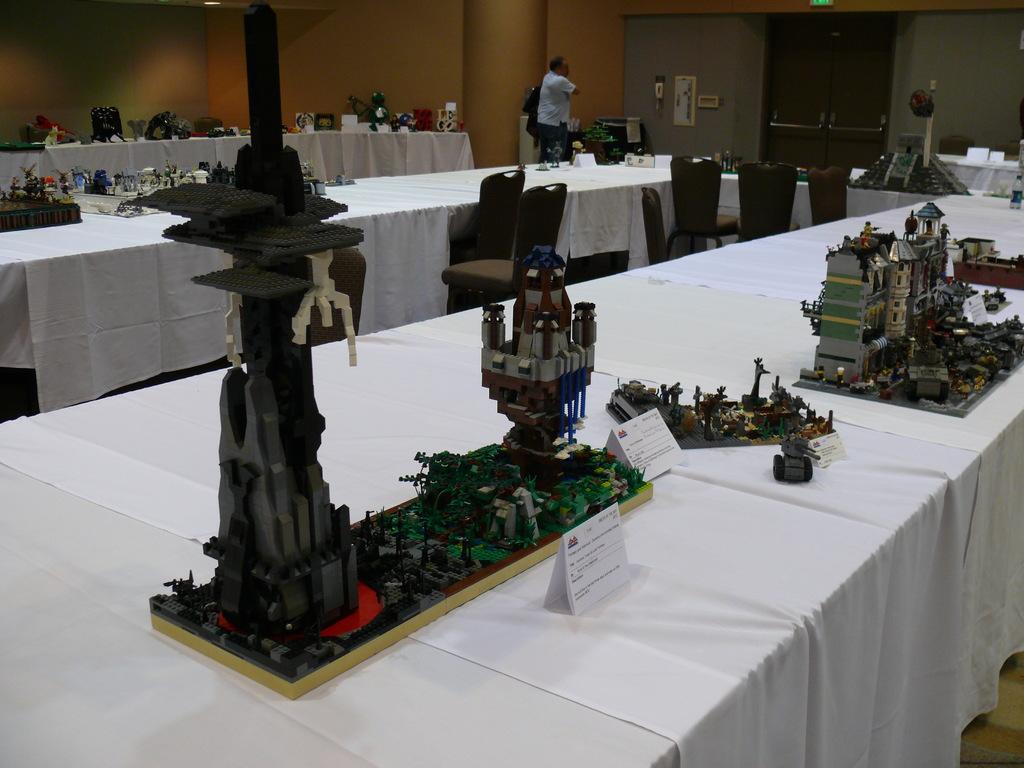How would you summarize this image in a sentence or two? In this image there are a few project works with some labels are arranged on the tables, in front of the tables there are chairs, there is a person standing, behind the person there is a pillar. In the background there are a few frames hanging on the wall and there is a door. 